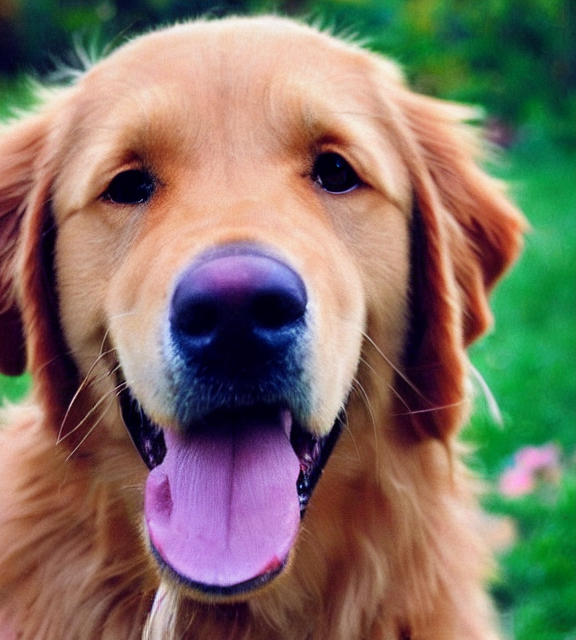What breed of dog is shown in this image? The dog in this image looks like a Golden Retriever, known for their friendly and tolerant attitude. 